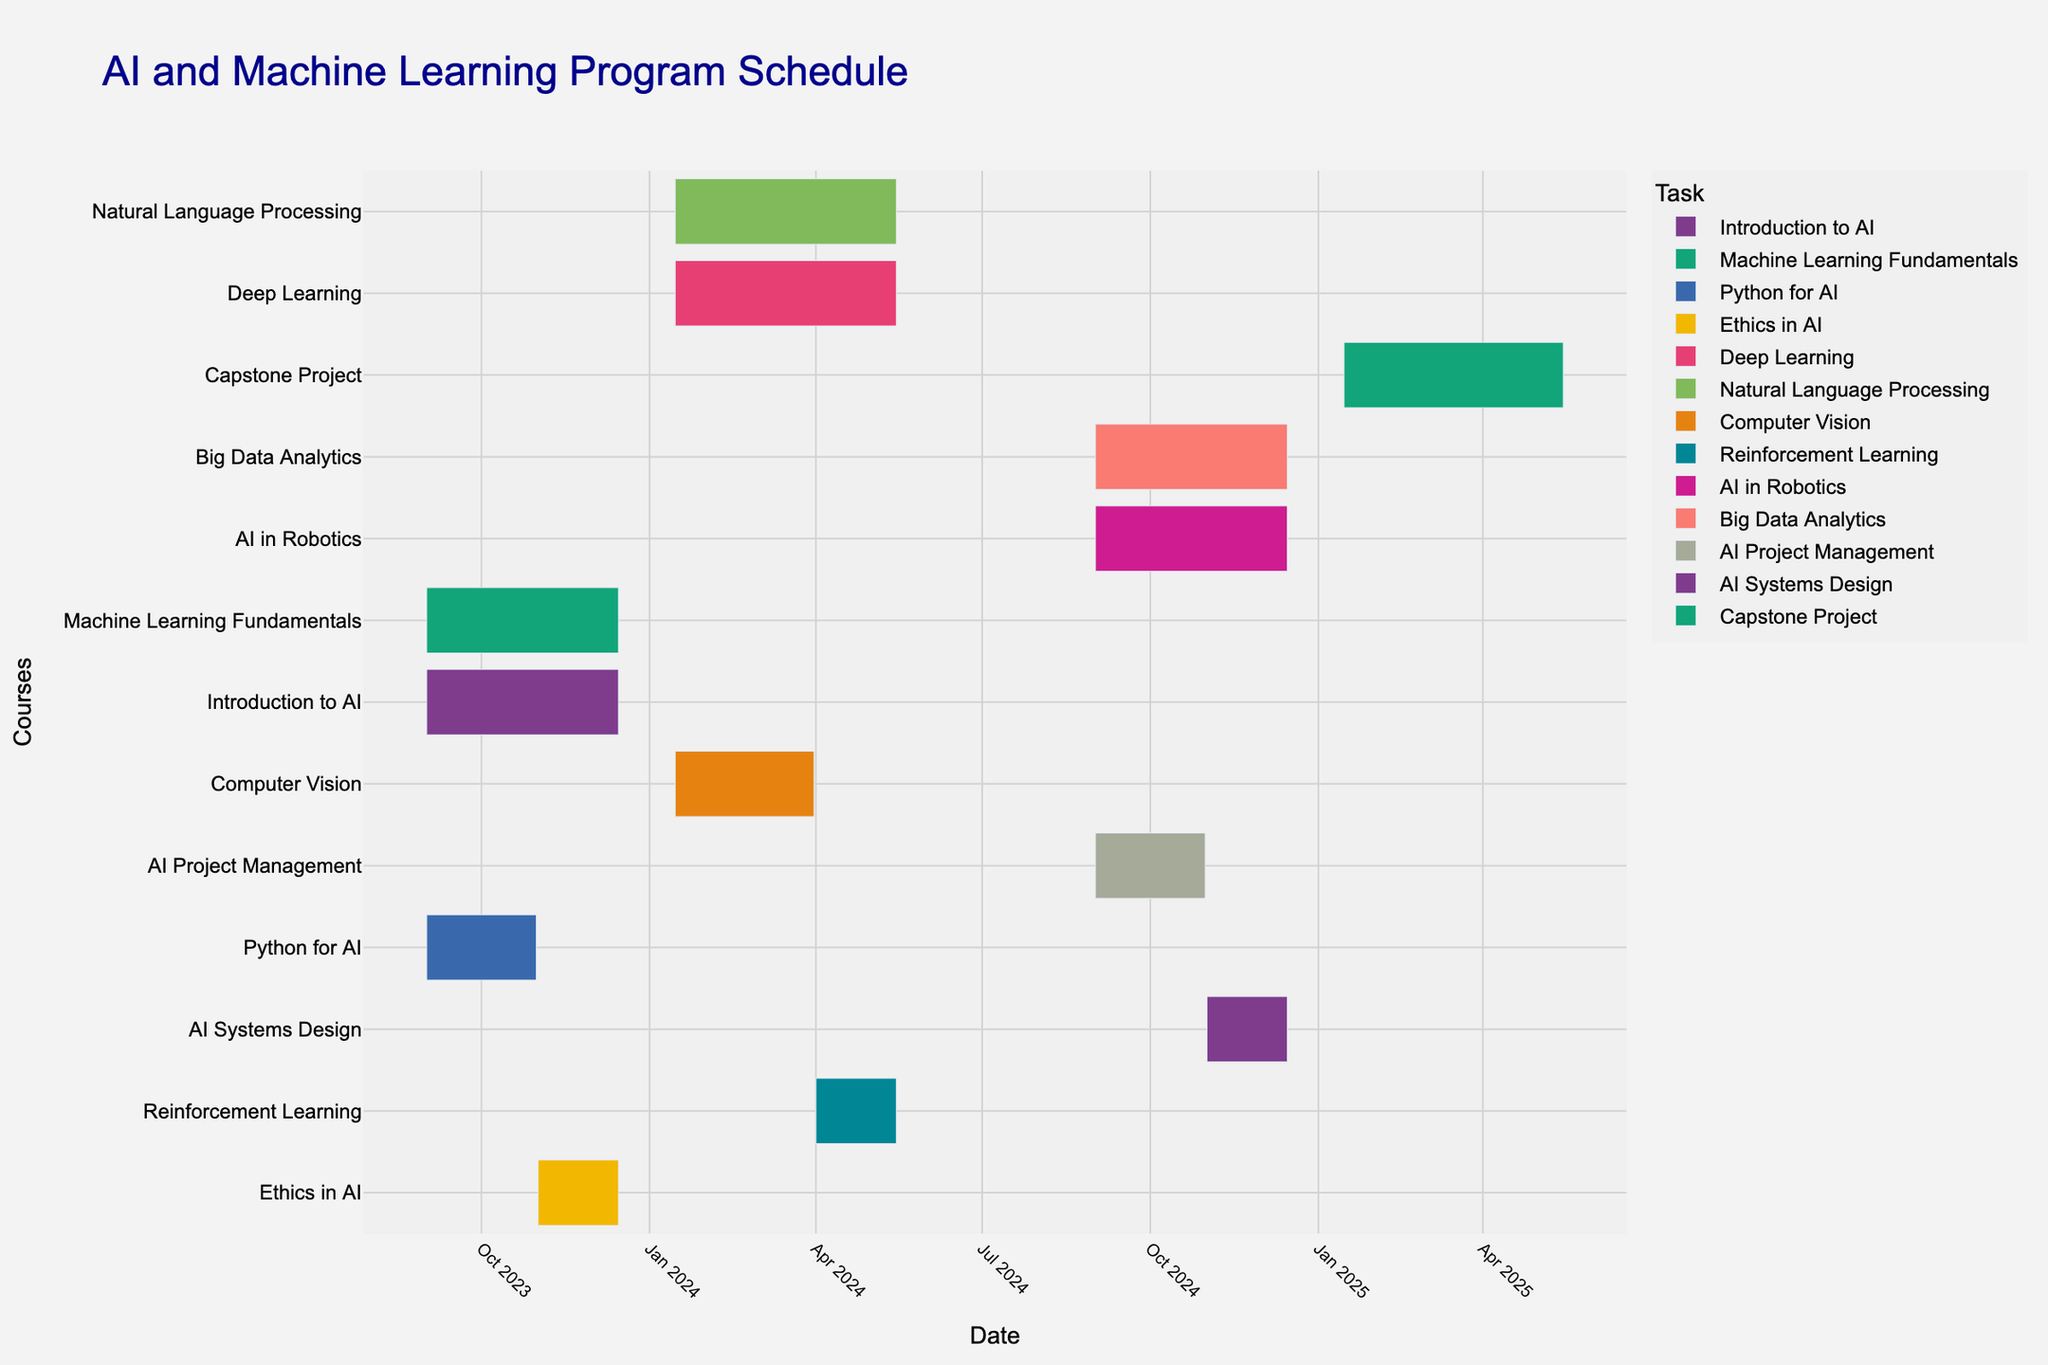What is the title of the Gantt chart? The title of the chart is usually found at the top of the figure and is used to provide a clear understanding of the chart's purpose. In this case, it should explain the content related to the course schedule.
Answer: AI and Machine Learning Program Schedule How many courses are scheduled in the first semester? The first semester appears to be from September 2023 to December 2023. By examining the courses within this time range, we count the number of tasks that start and end within these dates.
Answer: 4 Which course has the longest duration in the second semester? To determine the course with the longest duration between January 2024 and May 2024, we compare the start and end dates for each course in this period and identify the one with the longest span.
Answer: Deep Learning When does the "Ethics in AI" course start and end? By looking at the task labeled "Ethics in AI," we can directly read the start and end dates from the Gantt chart.
Answer: Starts: November 1, 2023; Ends: December 15, 2023 How many courses are scheduled to overlap in the third semester? The third semester seems to range from September 2024 to December 2024. By identifying courses within this period and checking their start and end dates, we determine how many have overlapping schedules.
Answer: 4 Compare the duration of "Python for AI" and "AI Project Management" courses. Which one is shorter? To compare their durations, we calculate the number of days each course spans by subtracting the start date from the end date and then compare the two values.
Answer: Python for AI is shorter What is the color coding used for different courses? The color coding helps differentiate between various courses visually. Each course is assigned a unique color.
Answer: Each course has a unique color, as per the color_discrete_sequence Which course is scheduled immediately after "Machine Learning Fundamentals"? By examining the end date of "Machine Learning Fundamentals" and locating the next course starting date in the subsequent periods, we can determine the next course.
Answer: Deep Learning How long is the "Capstone Project" scheduled for? The duration is calculated by subtracting the start date from the end date for the Capstone Project task on the Gantt chart.
Answer: 4 months Which courses are core subjects in the second semester? To determine which courses are core subjects, we identify and list the courses in the second semester and then verify if they are marked or identifiable as core subjects.
Answer: Deep Learning, Natural Language Processing, Computer Vision, Reinforcement Learning 